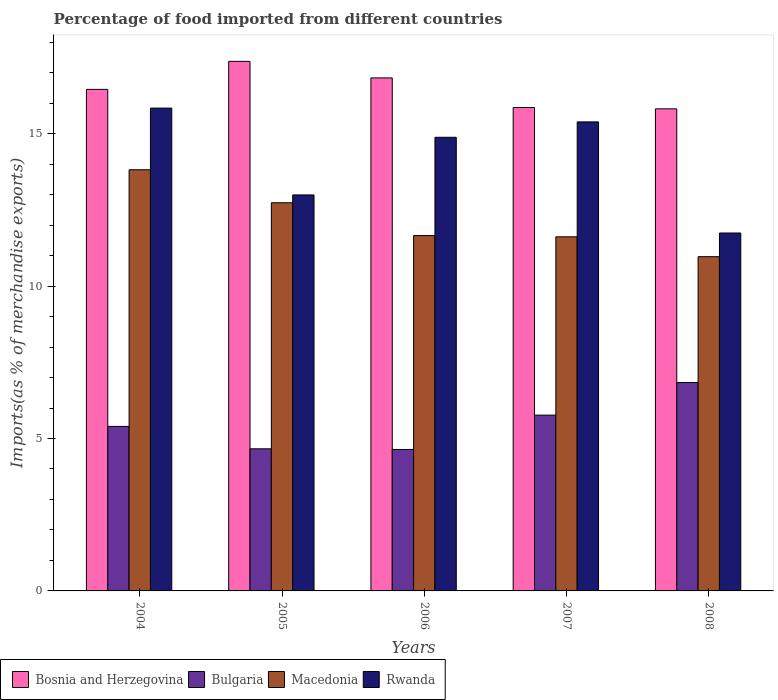How many different coloured bars are there?
Make the answer very short. 4. How many groups of bars are there?
Offer a terse response. 5. Are the number of bars on each tick of the X-axis equal?
Your response must be concise. Yes. How many bars are there on the 3rd tick from the left?
Make the answer very short. 4. What is the percentage of imports to different countries in Macedonia in 2007?
Provide a short and direct response. 11.62. Across all years, what is the maximum percentage of imports to different countries in Macedonia?
Make the answer very short. 13.82. Across all years, what is the minimum percentage of imports to different countries in Bulgaria?
Give a very brief answer. 4.64. In which year was the percentage of imports to different countries in Macedonia maximum?
Your answer should be very brief. 2004. What is the total percentage of imports to different countries in Bulgaria in the graph?
Offer a terse response. 27.3. What is the difference between the percentage of imports to different countries in Macedonia in 2005 and that in 2007?
Provide a succinct answer. 1.12. What is the difference between the percentage of imports to different countries in Rwanda in 2008 and the percentage of imports to different countries in Bulgaria in 2004?
Keep it short and to the point. 6.34. What is the average percentage of imports to different countries in Bosnia and Herzegovina per year?
Ensure brevity in your answer.  16.47. In the year 2008, what is the difference between the percentage of imports to different countries in Bosnia and Herzegovina and percentage of imports to different countries in Bulgaria?
Offer a terse response. 8.98. What is the ratio of the percentage of imports to different countries in Bosnia and Herzegovina in 2004 to that in 2005?
Give a very brief answer. 0.95. Is the difference between the percentage of imports to different countries in Bosnia and Herzegovina in 2005 and 2007 greater than the difference between the percentage of imports to different countries in Bulgaria in 2005 and 2007?
Make the answer very short. Yes. What is the difference between the highest and the second highest percentage of imports to different countries in Macedonia?
Offer a very short reply. 1.08. What is the difference between the highest and the lowest percentage of imports to different countries in Bulgaria?
Your answer should be very brief. 2.19. In how many years, is the percentage of imports to different countries in Macedonia greater than the average percentage of imports to different countries in Macedonia taken over all years?
Your answer should be very brief. 2. Is the sum of the percentage of imports to different countries in Macedonia in 2004 and 2008 greater than the maximum percentage of imports to different countries in Bulgaria across all years?
Make the answer very short. Yes. Is it the case that in every year, the sum of the percentage of imports to different countries in Bosnia and Herzegovina and percentage of imports to different countries in Macedonia is greater than the sum of percentage of imports to different countries in Bulgaria and percentage of imports to different countries in Rwanda?
Give a very brief answer. Yes. What does the 4th bar from the left in 2005 represents?
Your response must be concise. Rwanda. What does the 1st bar from the right in 2004 represents?
Your answer should be compact. Rwanda. How many bars are there?
Make the answer very short. 20. Are all the bars in the graph horizontal?
Your answer should be very brief. No. What is the difference between two consecutive major ticks on the Y-axis?
Provide a short and direct response. 5. Does the graph contain any zero values?
Keep it short and to the point. No. How are the legend labels stacked?
Offer a very short reply. Horizontal. What is the title of the graph?
Your response must be concise. Percentage of food imported from different countries. What is the label or title of the X-axis?
Offer a terse response. Years. What is the label or title of the Y-axis?
Your answer should be very brief. Imports(as % of merchandise exports). What is the Imports(as % of merchandise exports) in Bosnia and Herzegovina in 2004?
Your answer should be very brief. 16.45. What is the Imports(as % of merchandise exports) of Bulgaria in 2004?
Provide a succinct answer. 5.4. What is the Imports(as % of merchandise exports) in Macedonia in 2004?
Offer a terse response. 13.82. What is the Imports(as % of merchandise exports) of Rwanda in 2004?
Keep it short and to the point. 15.84. What is the Imports(as % of merchandise exports) of Bosnia and Herzegovina in 2005?
Your answer should be very brief. 17.37. What is the Imports(as % of merchandise exports) of Bulgaria in 2005?
Make the answer very short. 4.66. What is the Imports(as % of merchandise exports) of Macedonia in 2005?
Ensure brevity in your answer.  12.73. What is the Imports(as % of merchandise exports) of Rwanda in 2005?
Give a very brief answer. 12.99. What is the Imports(as % of merchandise exports) in Bosnia and Herzegovina in 2006?
Make the answer very short. 16.83. What is the Imports(as % of merchandise exports) in Bulgaria in 2006?
Keep it short and to the point. 4.64. What is the Imports(as % of merchandise exports) in Macedonia in 2006?
Offer a terse response. 11.66. What is the Imports(as % of merchandise exports) of Rwanda in 2006?
Provide a succinct answer. 14.88. What is the Imports(as % of merchandise exports) of Bosnia and Herzegovina in 2007?
Your answer should be very brief. 15.86. What is the Imports(as % of merchandise exports) of Bulgaria in 2007?
Provide a short and direct response. 5.77. What is the Imports(as % of merchandise exports) in Macedonia in 2007?
Your answer should be very brief. 11.62. What is the Imports(as % of merchandise exports) of Rwanda in 2007?
Offer a very short reply. 15.39. What is the Imports(as % of merchandise exports) of Bosnia and Herzegovina in 2008?
Your answer should be compact. 15.82. What is the Imports(as % of merchandise exports) in Bulgaria in 2008?
Offer a terse response. 6.84. What is the Imports(as % of merchandise exports) in Macedonia in 2008?
Give a very brief answer. 10.97. What is the Imports(as % of merchandise exports) of Rwanda in 2008?
Offer a very short reply. 11.74. Across all years, what is the maximum Imports(as % of merchandise exports) in Bosnia and Herzegovina?
Give a very brief answer. 17.37. Across all years, what is the maximum Imports(as % of merchandise exports) of Bulgaria?
Provide a succinct answer. 6.84. Across all years, what is the maximum Imports(as % of merchandise exports) of Macedonia?
Provide a succinct answer. 13.82. Across all years, what is the maximum Imports(as % of merchandise exports) of Rwanda?
Make the answer very short. 15.84. Across all years, what is the minimum Imports(as % of merchandise exports) of Bosnia and Herzegovina?
Offer a terse response. 15.82. Across all years, what is the minimum Imports(as % of merchandise exports) of Bulgaria?
Offer a very short reply. 4.64. Across all years, what is the minimum Imports(as % of merchandise exports) of Macedonia?
Provide a succinct answer. 10.97. Across all years, what is the minimum Imports(as % of merchandise exports) in Rwanda?
Offer a very short reply. 11.74. What is the total Imports(as % of merchandise exports) in Bosnia and Herzegovina in the graph?
Give a very brief answer. 82.33. What is the total Imports(as % of merchandise exports) of Bulgaria in the graph?
Make the answer very short. 27.3. What is the total Imports(as % of merchandise exports) of Macedonia in the graph?
Your answer should be very brief. 60.79. What is the total Imports(as % of merchandise exports) of Rwanda in the graph?
Your response must be concise. 70.84. What is the difference between the Imports(as % of merchandise exports) in Bosnia and Herzegovina in 2004 and that in 2005?
Provide a succinct answer. -0.92. What is the difference between the Imports(as % of merchandise exports) in Bulgaria in 2004 and that in 2005?
Your answer should be very brief. 0.73. What is the difference between the Imports(as % of merchandise exports) of Macedonia in 2004 and that in 2005?
Your answer should be compact. 1.08. What is the difference between the Imports(as % of merchandise exports) of Rwanda in 2004 and that in 2005?
Your answer should be very brief. 2.85. What is the difference between the Imports(as % of merchandise exports) of Bosnia and Herzegovina in 2004 and that in 2006?
Provide a short and direct response. -0.38. What is the difference between the Imports(as % of merchandise exports) of Bulgaria in 2004 and that in 2006?
Your answer should be very brief. 0.76. What is the difference between the Imports(as % of merchandise exports) in Macedonia in 2004 and that in 2006?
Make the answer very short. 2.16. What is the difference between the Imports(as % of merchandise exports) of Rwanda in 2004 and that in 2006?
Offer a very short reply. 0.96. What is the difference between the Imports(as % of merchandise exports) in Bosnia and Herzegovina in 2004 and that in 2007?
Make the answer very short. 0.6. What is the difference between the Imports(as % of merchandise exports) of Bulgaria in 2004 and that in 2007?
Your answer should be compact. -0.37. What is the difference between the Imports(as % of merchandise exports) in Macedonia in 2004 and that in 2007?
Your response must be concise. 2.2. What is the difference between the Imports(as % of merchandise exports) in Rwanda in 2004 and that in 2007?
Make the answer very short. 0.45. What is the difference between the Imports(as % of merchandise exports) in Bosnia and Herzegovina in 2004 and that in 2008?
Your answer should be very brief. 0.64. What is the difference between the Imports(as % of merchandise exports) in Bulgaria in 2004 and that in 2008?
Your answer should be very brief. -1.44. What is the difference between the Imports(as % of merchandise exports) of Macedonia in 2004 and that in 2008?
Your answer should be compact. 2.85. What is the difference between the Imports(as % of merchandise exports) in Rwanda in 2004 and that in 2008?
Provide a short and direct response. 4.1. What is the difference between the Imports(as % of merchandise exports) in Bosnia and Herzegovina in 2005 and that in 2006?
Your answer should be compact. 0.54. What is the difference between the Imports(as % of merchandise exports) of Bulgaria in 2005 and that in 2006?
Offer a very short reply. 0.02. What is the difference between the Imports(as % of merchandise exports) of Macedonia in 2005 and that in 2006?
Give a very brief answer. 1.08. What is the difference between the Imports(as % of merchandise exports) of Rwanda in 2005 and that in 2006?
Keep it short and to the point. -1.89. What is the difference between the Imports(as % of merchandise exports) of Bosnia and Herzegovina in 2005 and that in 2007?
Keep it short and to the point. 1.52. What is the difference between the Imports(as % of merchandise exports) in Bulgaria in 2005 and that in 2007?
Ensure brevity in your answer.  -1.11. What is the difference between the Imports(as % of merchandise exports) in Macedonia in 2005 and that in 2007?
Offer a terse response. 1.12. What is the difference between the Imports(as % of merchandise exports) of Rwanda in 2005 and that in 2007?
Keep it short and to the point. -2.4. What is the difference between the Imports(as % of merchandise exports) of Bosnia and Herzegovina in 2005 and that in 2008?
Your answer should be very brief. 1.56. What is the difference between the Imports(as % of merchandise exports) of Bulgaria in 2005 and that in 2008?
Provide a succinct answer. -2.17. What is the difference between the Imports(as % of merchandise exports) in Macedonia in 2005 and that in 2008?
Give a very brief answer. 1.77. What is the difference between the Imports(as % of merchandise exports) of Rwanda in 2005 and that in 2008?
Provide a short and direct response. 1.25. What is the difference between the Imports(as % of merchandise exports) in Bosnia and Herzegovina in 2006 and that in 2007?
Give a very brief answer. 0.97. What is the difference between the Imports(as % of merchandise exports) in Bulgaria in 2006 and that in 2007?
Provide a succinct answer. -1.13. What is the difference between the Imports(as % of merchandise exports) in Macedonia in 2006 and that in 2007?
Provide a short and direct response. 0.04. What is the difference between the Imports(as % of merchandise exports) in Rwanda in 2006 and that in 2007?
Your answer should be compact. -0.5. What is the difference between the Imports(as % of merchandise exports) in Bosnia and Herzegovina in 2006 and that in 2008?
Make the answer very short. 1.01. What is the difference between the Imports(as % of merchandise exports) of Bulgaria in 2006 and that in 2008?
Provide a short and direct response. -2.19. What is the difference between the Imports(as % of merchandise exports) in Macedonia in 2006 and that in 2008?
Provide a succinct answer. 0.69. What is the difference between the Imports(as % of merchandise exports) of Rwanda in 2006 and that in 2008?
Offer a terse response. 3.14. What is the difference between the Imports(as % of merchandise exports) in Bosnia and Herzegovina in 2007 and that in 2008?
Give a very brief answer. 0.04. What is the difference between the Imports(as % of merchandise exports) in Bulgaria in 2007 and that in 2008?
Offer a terse response. -1.07. What is the difference between the Imports(as % of merchandise exports) in Macedonia in 2007 and that in 2008?
Offer a very short reply. 0.65. What is the difference between the Imports(as % of merchandise exports) in Rwanda in 2007 and that in 2008?
Ensure brevity in your answer.  3.65. What is the difference between the Imports(as % of merchandise exports) of Bosnia and Herzegovina in 2004 and the Imports(as % of merchandise exports) of Bulgaria in 2005?
Provide a succinct answer. 11.79. What is the difference between the Imports(as % of merchandise exports) in Bosnia and Herzegovina in 2004 and the Imports(as % of merchandise exports) in Macedonia in 2005?
Provide a short and direct response. 3.72. What is the difference between the Imports(as % of merchandise exports) in Bosnia and Herzegovina in 2004 and the Imports(as % of merchandise exports) in Rwanda in 2005?
Keep it short and to the point. 3.46. What is the difference between the Imports(as % of merchandise exports) of Bulgaria in 2004 and the Imports(as % of merchandise exports) of Macedonia in 2005?
Offer a very short reply. -7.34. What is the difference between the Imports(as % of merchandise exports) of Bulgaria in 2004 and the Imports(as % of merchandise exports) of Rwanda in 2005?
Provide a succinct answer. -7.59. What is the difference between the Imports(as % of merchandise exports) in Macedonia in 2004 and the Imports(as % of merchandise exports) in Rwanda in 2005?
Your answer should be compact. 0.83. What is the difference between the Imports(as % of merchandise exports) in Bosnia and Herzegovina in 2004 and the Imports(as % of merchandise exports) in Bulgaria in 2006?
Ensure brevity in your answer.  11.81. What is the difference between the Imports(as % of merchandise exports) in Bosnia and Herzegovina in 2004 and the Imports(as % of merchandise exports) in Macedonia in 2006?
Ensure brevity in your answer.  4.8. What is the difference between the Imports(as % of merchandise exports) in Bosnia and Herzegovina in 2004 and the Imports(as % of merchandise exports) in Rwanda in 2006?
Provide a short and direct response. 1.57. What is the difference between the Imports(as % of merchandise exports) of Bulgaria in 2004 and the Imports(as % of merchandise exports) of Macedonia in 2006?
Your response must be concise. -6.26. What is the difference between the Imports(as % of merchandise exports) in Bulgaria in 2004 and the Imports(as % of merchandise exports) in Rwanda in 2006?
Ensure brevity in your answer.  -9.48. What is the difference between the Imports(as % of merchandise exports) in Macedonia in 2004 and the Imports(as % of merchandise exports) in Rwanda in 2006?
Offer a terse response. -1.06. What is the difference between the Imports(as % of merchandise exports) of Bosnia and Herzegovina in 2004 and the Imports(as % of merchandise exports) of Bulgaria in 2007?
Make the answer very short. 10.69. What is the difference between the Imports(as % of merchandise exports) of Bosnia and Herzegovina in 2004 and the Imports(as % of merchandise exports) of Macedonia in 2007?
Your answer should be compact. 4.84. What is the difference between the Imports(as % of merchandise exports) of Bosnia and Herzegovina in 2004 and the Imports(as % of merchandise exports) of Rwanda in 2007?
Keep it short and to the point. 1.07. What is the difference between the Imports(as % of merchandise exports) of Bulgaria in 2004 and the Imports(as % of merchandise exports) of Macedonia in 2007?
Your answer should be very brief. -6.22. What is the difference between the Imports(as % of merchandise exports) of Bulgaria in 2004 and the Imports(as % of merchandise exports) of Rwanda in 2007?
Make the answer very short. -9.99. What is the difference between the Imports(as % of merchandise exports) of Macedonia in 2004 and the Imports(as % of merchandise exports) of Rwanda in 2007?
Your answer should be very brief. -1.57. What is the difference between the Imports(as % of merchandise exports) in Bosnia and Herzegovina in 2004 and the Imports(as % of merchandise exports) in Bulgaria in 2008?
Give a very brief answer. 9.62. What is the difference between the Imports(as % of merchandise exports) of Bosnia and Herzegovina in 2004 and the Imports(as % of merchandise exports) of Macedonia in 2008?
Make the answer very short. 5.49. What is the difference between the Imports(as % of merchandise exports) in Bosnia and Herzegovina in 2004 and the Imports(as % of merchandise exports) in Rwanda in 2008?
Ensure brevity in your answer.  4.71. What is the difference between the Imports(as % of merchandise exports) of Bulgaria in 2004 and the Imports(as % of merchandise exports) of Macedonia in 2008?
Offer a very short reply. -5.57. What is the difference between the Imports(as % of merchandise exports) in Bulgaria in 2004 and the Imports(as % of merchandise exports) in Rwanda in 2008?
Ensure brevity in your answer.  -6.34. What is the difference between the Imports(as % of merchandise exports) of Macedonia in 2004 and the Imports(as % of merchandise exports) of Rwanda in 2008?
Your answer should be very brief. 2.08. What is the difference between the Imports(as % of merchandise exports) in Bosnia and Herzegovina in 2005 and the Imports(as % of merchandise exports) in Bulgaria in 2006?
Your answer should be very brief. 12.73. What is the difference between the Imports(as % of merchandise exports) of Bosnia and Herzegovina in 2005 and the Imports(as % of merchandise exports) of Macedonia in 2006?
Keep it short and to the point. 5.72. What is the difference between the Imports(as % of merchandise exports) in Bosnia and Herzegovina in 2005 and the Imports(as % of merchandise exports) in Rwanda in 2006?
Your response must be concise. 2.49. What is the difference between the Imports(as % of merchandise exports) of Bulgaria in 2005 and the Imports(as % of merchandise exports) of Macedonia in 2006?
Make the answer very short. -7. What is the difference between the Imports(as % of merchandise exports) in Bulgaria in 2005 and the Imports(as % of merchandise exports) in Rwanda in 2006?
Make the answer very short. -10.22. What is the difference between the Imports(as % of merchandise exports) in Macedonia in 2005 and the Imports(as % of merchandise exports) in Rwanda in 2006?
Provide a succinct answer. -2.15. What is the difference between the Imports(as % of merchandise exports) in Bosnia and Herzegovina in 2005 and the Imports(as % of merchandise exports) in Bulgaria in 2007?
Keep it short and to the point. 11.61. What is the difference between the Imports(as % of merchandise exports) in Bosnia and Herzegovina in 2005 and the Imports(as % of merchandise exports) in Macedonia in 2007?
Give a very brief answer. 5.76. What is the difference between the Imports(as % of merchandise exports) of Bosnia and Herzegovina in 2005 and the Imports(as % of merchandise exports) of Rwanda in 2007?
Your response must be concise. 1.99. What is the difference between the Imports(as % of merchandise exports) of Bulgaria in 2005 and the Imports(as % of merchandise exports) of Macedonia in 2007?
Keep it short and to the point. -6.95. What is the difference between the Imports(as % of merchandise exports) in Bulgaria in 2005 and the Imports(as % of merchandise exports) in Rwanda in 2007?
Provide a short and direct response. -10.72. What is the difference between the Imports(as % of merchandise exports) in Macedonia in 2005 and the Imports(as % of merchandise exports) in Rwanda in 2007?
Your answer should be compact. -2.65. What is the difference between the Imports(as % of merchandise exports) in Bosnia and Herzegovina in 2005 and the Imports(as % of merchandise exports) in Bulgaria in 2008?
Your response must be concise. 10.54. What is the difference between the Imports(as % of merchandise exports) of Bosnia and Herzegovina in 2005 and the Imports(as % of merchandise exports) of Macedonia in 2008?
Provide a succinct answer. 6.41. What is the difference between the Imports(as % of merchandise exports) of Bosnia and Herzegovina in 2005 and the Imports(as % of merchandise exports) of Rwanda in 2008?
Your answer should be very brief. 5.63. What is the difference between the Imports(as % of merchandise exports) in Bulgaria in 2005 and the Imports(as % of merchandise exports) in Macedonia in 2008?
Your answer should be compact. -6.3. What is the difference between the Imports(as % of merchandise exports) of Bulgaria in 2005 and the Imports(as % of merchandise exports) of Rwanda in 2008?
Offer a terse response. -7.08. What is the difference between the Imports(as % of merchandise exports) in Macedonia in 2005 and the Imports(as % of merchandise exports) in Rwanda in 2008?
Give a very brief answer. 0.99. What is the difference between the Imports(as % of merchandise exports) in Bosnia and Herzegovina in 2006 and the Imports(as % of merchandise exports) in Bulgaria in 2007?
Keep it short and to the point. 11.06. What is the difference between the Imports(as % of merchandise exports) in Bosnia and Herzegovina in 2006 and the Imports(as % of merchandise exports) in Macedonia in 2007?
Give a very brief answer. 5.21. What is the difference between the Imports(as % of merchandise exports) of Bosnia and Herzegovina in 2006 and the Imports(as % of merchandise exports) of Rwanda in 2007?
Your response must be concise. 1.44. What is the difference between the Imports(as % of merchandise exports) in Bulgaria in 2006 and the Imports(as % of merchandise exports) in Macedonia in 2007?
Offer a very short reply. -6.98. What is the difference between the Imports(as % of merchandise exports) of Bulgaria in 2006 and the Imports(as % of merchandise exports) of Rwanda in 2007?
Offer a very short reply. -10.75. What is the difference between the Imports(as % of merchandise exports) of Macedonia in 2006 and the Imports(as % of merchandise exports) of Rwanda in 2007?
Keep it short and to the point. -3.73. What is the difference between the Imports(as % of merchandise exports) of Bosnia and Herzegovina in 2006 and the Imports(as % of merchandise exports) of Bulgaria in 2008?
Ensure brevity in your answer.  9.99. What is the difference between the Imports(as % of merchandise exports) in Bosnia and Herzegovina in 2006 and the Imports(as % of merchandise exports) in Macedonia in 2008?
Offer a very short reply. 5.86. What is the difference between the Imports(as % of merchandise exports) in Bosnia and Herzegovina in 2006 and the Imports(as % of merchandise exports) in Rwanda in 2008?
Provide a succinct answer. 5.09. What is the difference between the Imports(as % of merchandise exports) in Bulgaria in 2006 and the Imports(as % of merchandise exports) in Macedonia in 2008?
Provide a succinct answer. -6.32. What is the difference between the Imports(as % of merchandise exports) in Bulgaria in 2006 and the Imports(as % of merchandise exports) in Rwanda in 2008?
Make the answer very short. -7.1. What is the difference between the Imports(as % of merchandise exports) in Macedonia in 2006 and the Imports(as % of merchandise exports) in Rwanda in 2008?
Your response must be concise. -0.08. What is the difference between the Imports(as % of merchandise exports) in Bosnia and Herzegovina in 2007 and the Imports(as % of merchandise exports) in Bulgaria in 2008?
Offer a terse response. 9.02. What is the difference between the Imports(as % of merchandise exports) of Bosnia and Herzegovina in 2007 and the Imports(as % of merchandise exports) of Macedonia in 2008?
Ensure brevity in your answer.  4.89. What is the difference between the Imports(as % of merchandise exports) in Bosnia and Herzegovina in 2007 and the Imports(as % of merchandise exports) in Rwanda in 2008?
Offer a terse response. 4.12. What is the difference between the Imports(as % of merchandise exports) in Bulgaria in 2007 and the Imports(as % of merchandise exports) in Macedonia in 2008?
Offer a very short reply. -5.2. What is the difference between the Imports(as % of merchandise exports) of Bulgaria in 2007 and the Imports(as % of merchandise exports) of Rwanda in 2008?
Your answer should be very brief. -5.97. What is the difference between the Imports(as % of merchandise exports) in Macedonia in 2007 and the Imports(as % of merchandise exports) in Rwanda in 2008?
Your response must be concise. -0.13. What is the average Imports(as % of merchandise exports) of Bosnia and Herzegovina per year?
Keep it short and to the point. 16.47. What is the average Imports(as % of merchandise exports) in Bulgaria per year?
Your response must be concise. 5.46. What is the average Imports(as % of merchandise exports) of Macedonia per year?
Your response must be concise. 12.16. What is the average Imports(as % of merchandise exports) in Rwanda per year?
Keep it short and to the point. 14.17. In the year 2004, what is the difference between the Imports(as % of merchandise exports) of Bosnia and Herzegovina and Imports(as % of merchandise exports) of Bulgaria?
Offer a terse response. 11.06. In the year 2004, what is the difference between the Imports(as % of merchandise exports) in Bosnia and Herzegovina and Imports(as % of merchandise exports) in Macedonia?
Offer a very short reply. 2.64. In the year 2004, what is the difference between the Imports(as % of merchandise exports) in Bosnia and Herzegovina and Imports(as % of merchandise exports) in Rwanda?
Ensure brevity in your answer.  0.61. In the year 2004, what is the difference between the Imports(as % of merchandise exports) in Bulgaria and Imports(as % of merchandise exports) in Macedonia?
Make the answer very short. -8.42. In the year 2004, what is the difference between the Imports(as % of merchandise exports) of Bulgaria and Imports(as % of merchandise exports) of Rwanda?
Offer a very short reply. -10.44. In the year 2004, what is the difference between the Imports(as % of merchandise exports) in Macedonia and Imports(as % of merchandise exports) in Rwanda?
Ensure brevity in your answer.  -2.02. In the year 2005, what is the difference between the Imports(as % of merchandise exports) in Bosnia and Herzegovina and Imports(as % of merchandise exports) in Bulgaria?
Make the answer very short. 12.71. In the year 2005, what is the difference between the Imports(as % of merchandise exports) of Bosnia and Herzegovina and Imports(as % of merchandise exports) of Macedonia?
Offer a very short reply. 4.64. In the year 2005, what is the difference between the Imports(as % of merchandise exports) in Bosnia and Herzegovina and Imports(as % of merchandise exports) in Rwanda?
Make the answer very short. 4.38. In the year 2005, what is the difference between the Imports(as % of merchandise exports) in Bulgaria and Imports(as % of merchandise exports) in Macedonia?
Ensure brevity in your answer.  -8.07. In the year 2005, what is the difference between the Imports(as % of merchandise exports) in Bulgaria and Imports(as % of merchandise exports) in Rwanda?
Make the answer very short. -8.33. In the year 2005, what is the difference between the Imports(as % of merchandise exports) of Macedonia and Imports(as % of merchandise exports) of Rwanda?
Your response must be concise. -0.26. In the year 2006, what is the difference between the Imports(as % of merchandise exports) of Bosnia and Herzegovina and Imports(as % of merchandise exports) of Bulgaria?
Provide a short and direct response. 12.19. In the year 2006, what is the difference between the Imports(as % of merchandise exports) of Bosnia and Herzegovina and Imports(as % of merchandise exports) of Macedonia?
Offer a terse response. 5.17. In the year 2006, what is the difference between the Imports(as % of merchandise exports) in Bosnia and Herzegovina and Imports(as % of merchandise exports) in Rwanda?
Your answer should be compact. 1.95. In the year 2006, what is the difference between the Imports(as % of merchandise exports) in Bulgaria and Imports(as % of merchandise exports) in Macedonia?
Offer a terse response. -7.02. In the year 2006, what is the difference between the Imports(as % of merchandise exports) in Bulgaria and Imports(as % of merchandise exports) in Rwanda?
Ensure brevity in your answer.  -10.24. In the year 2006, what is the difference between the Imports(as % of merchandise exports) in Macedonia and Imports(as % of merchandise exports) in Rwanda?
Offer a very short reply. -3.22. In the year 2007, what is the difference between the Imports(as % of merchandise exports) of Bosnia and Herzegovina and Imports(as % of merchandise exports) of Bulgaria?
Your answer should be very brief. 10.09. In the year 2007, what is the difference between the Imports(as % of merchandise exports) in Bosnia and Herzegovina and Imports(as % of merchandise exports) in Macedonia?
Your answer should be compact. 4.24. In the year 2007, what is the difference between the Imports(as % of merchandise exports) in Bosnia and Herzegovina and Imports(as % of merchandise exports) in Rwanda?
Your answer should be very brief. 0.47. In the year 2007, what is the difference between the Imports(as % of merchandise exports) in Bulgaria and Imports(as % of merchandise exports) in Macedonia?
Provide a short and direct response. -5.85. In the year 2007, what is the difference between the Imports(as % of merchandise exports) of Bulgaria and Imports(as % of merchandise exports) of Rwanda?
Offer a very short reply. -9.62. In the year 2007, what is the difference between the Imports(as % of merchandise exports) of Macedonia and Imports(as % of merchandise exports) of Rwanda?
Make the answer very short. -3.77. In the year 2008, what is the difference between the Imports(as % of merchandise exports) in Bosnia and Herzegovina and Imports(as % of merchandise exports) in Bulgaria?
Make the answer very short. 8.98. In the year 2008, what is the difference between the Imports(as % of merchandise exports) in Bosnia and Herzegovina and Imports(as % of merchandise exports) in Macedonia?
Offer a very short reply. 4.85. In the year 2008, what is the difference between the Imports(as % of merchandise exports) of Bosnia and Herzegovina and Imports(as % of merchandise exports) of Rwanda?
Offer a very short reply. 4.07. In the year 2008, what is the difference between the Imports(as % of merchandise exports) in Bulgaria and Imports(as % of merchandise exports) in Macedonia?
Offer a very short reply. -4.13. In the year 2008, what is the difference between the Imports(as % of merchandise exports) in Bulgaria and Imports(as % of merchandise exports) in Rwanda?
Provide a succinct answer. -4.91. In the year 2008, what is the difference between the Imports(as % of merchandise exports) of Macedonia and Imports(as % of merchandise exports) of Rwanda?
Your response must be concise. -0.78. What is the ratio of the Imports(as % of merchandise exports) of Bosnia and Herzegovina in 2004 to that in 2005?
Provide a succinct answer. 0.95. What is the ratio of the Imports(as % of merchandise exports) in Bulgaria in 2004 to that in 2005?
Your response must be concise. 1.16. What is the ratio of the Imports(as % of merchandise exports) in Macedonia in 2004 to that in 2005?
Offer a very short reply. 1.08. What is the ratio of the Imports(as % of merchandise exports) of Rwanda in 2004 to that in 2005?
Provide a succinct answer. 1.22. What is the ratio of the Imports(as % of merchandise exports) of Bosnia and Herzegovina in 2004 to that in 2006?
Provide a short and direct response. 0.98. What is the ratio of the Imports(as % of merchandise exports) in Bulgaria in 2004 to that in 2006?
Make the answer very short. 1.16. What is the ratio of the Imports(as % of merchandise exports) of Macedonia in 2004 to that in 2006?
Keep it short and to the point. 1.19. What is the ratio of the Imports(as % of merchandise exports) of Rwanda in 2004 to that in 2006?
Offer a very short reply. 1.06. What is the ratio of the Imports(as % of merchandise exports) in Bosnia and Herzegovina in 2004 to that in 2007?
Provide a succinct answer. 1.04. What is the ratio of the Imports(as % of merchandise exports) of Bulgaria in 2004 to that in 2007?
Your response must be concise. 0.94. What is the ratio of the Imports(as % of merchandise exports) in Macedonia in 2004 to that in 2007?
Provide a succinct answer. 1.19. What is the ratio of the Imports(as % of merchandise exports) in Rwanda in 2004 to that in 2007?
Keep it short and to the point. 1.03. What is the ratio of the Imports(as % of merchandise exports) in Bosnia and Herzegovina in 2004 to that in 2008?
Provide a succinct answer. 1.04. What is the ratio of the Imports(as % of merchandise exports) of Bulgaria in 2004 to that in 2008?
Your answer should be compact. 0.79. What is the ratio of the Imports(as % of merchandise exports) of Macedonia in 2004 to that in 2008?
Keep it short and to the point. 1.26. What is the ratio of the Imports(as % of merchandise exports) in Rwanda in 2004 to that in 2008?
Your answer should be compact. 1.35. What is the ratio of the Imports(as % of merchandise exports) of Bosnia and Herzegovina in 2005 to that in 2006?
Keep it short and to the point. 1.03. What is the ratio of the Imports(as % of merchandise exports) of Bulgaria in 2005 to that in 2006?
Keep it short and to the point. 1. What is the ratio of the Imports(as % of merchandise exports) of Macedonia in 2005 to that in 2006?
Offer a very short reply. 1.09. What is the ratio of the Imports(as % of merchandise exports) in Rwanda in 2005 to that in 2006?
Keep it short and to the point. 0.87. What is the ratio of the Imports(as % of merchandise exports) of Bosnia and Herzegovina in 2005 to that in 2007?
Ensure brevity in your answer.  1.1. What is the ratio of the Imports(as % of merchandise exports) of Bulgaria in 2005 to that in 2007?
Ensure brevity in your answer.  0.81. What is the ratio of the Imports(as % of merchandise exports) in Macedonia in 2005 to that in 2007?
Offer a terse response. 1.1. What is the ratio of the Imports(as % of merchandise exports) of Rwanda in 2005 to that in 2007?
Give a very brief answer. 0.84. What is the ratio of the Imports(as % of merchandise exports) of Bosnia and Herzegovina in 2005 to that in 2008?
Give a very brief answer. 1.1. What is the ratio of the Imports(as % of merchandise exports) in Bulgaria in 2005 to that in 2008?
Ensure brevity in your answer.  0.68. What is the ratio of the Imports(as % of merchandise exports) in Macedonia in 2005 to that in 2008?
Ensure brevity in your answer.  1.16. What is the ratio of the Imports(as % of merchandise exports) of Rwanda in 2005 to that in 2008?
Your answer should be very brief. 1.11. What is the ratio of the Imports(as % of merchandise exports) in Bosnia and Herzegovina in 2006 to that in 2007?
Ensure brevity in your answer.  1.06. What is the ratio of the Imports(as % of merchandise exports) of Bulgaria in 2006 to that in 2007?
Provide a succinct answer. 0.8. What is the ratio of the Imports(as % of merchandise exports) in Macedonia in 2006 to that in 2007?
Keep it short and to the point. 1. What is the ratio of the Imports(as % of merchandise exports) in Rwanda in 2006 to that in 2007?
Your answer should be compact. 0.97. What is the ratio of the Imports(as % of merchandise exports) in Bosnia and Herzegovina in 2006 to that in 2008?
Your response must be concise. 1.06. What is the ratio of the Imports(as % of merchandise exports) of Bulgaria in 2006 to that in 2008?
Provide a short and direct response. 0.68. What is the ratio of the Imports(as % of merchandise exports) of Macedonia in 2006 to that in 2008?
Ensure brevity in your answer.  1.06. What is the ratio of the Imports(as % of merchandise exports) of Rwanda in 2006 to that in 2008?
Your response must be concise. 1.27. What is the ratio of the Imports(as % of merchandise exports) in Bosnia and Herzegovina in 2007 to that in 2008?
Ensure brevity in your answer.  1. What is the ratio of the Imports(as % of merchandise exports) of Bulgaria in 2007 to that in 2008?
Your response must be concise. 0.84. What is the ratio of the Imports(as % of merchandise exports) in Macedonia in 2007 to that in 2008?
Offer a very short reply. 1.06. What is the ratio of the Imports(as % of merchandise exports) in Rwanda in 2007 to that in 2008?
Provide a succinct answer. 1.31. What is the difference between the highest and the second highest Imports(as % of merchandise exports) in Bosnia and Herzegovina?
Ensure brevity in your answer.  0.54. What is the difference between the highest and the second highest Imports(as % of merchandise exports) in Bulgaria?
Provide a succinct answer. 1.07. What is the difference between the highest and the second highest Imports(as % of merchandise exports) of Macedonia?
Your answer should be very brief. 1.08. What is the difference between the highest and the second highest Imports(as % of merchandise exports) in Rwanda?
Your answer should be compact. 0.45. What is the difference between the highest and the lowest Imports(as % of merchandise exports) of Bosnia and Herzegovina?
Your answer should be very brief. 1.56. What is the difference between the highest and the lowest Imports(as % of merchandise exports) of Bulgaria?
Provide a short and direct response. 2.19. What is the difference between the highest and the lowest Imports(as % of merchandise exports) in Macedonia?
Your answer should be compact. 2.85. What is the difference between the highest and the lowest Imports(as % of merchandise exports) in Rwanda?
Offer a very short reply. 4.1. 